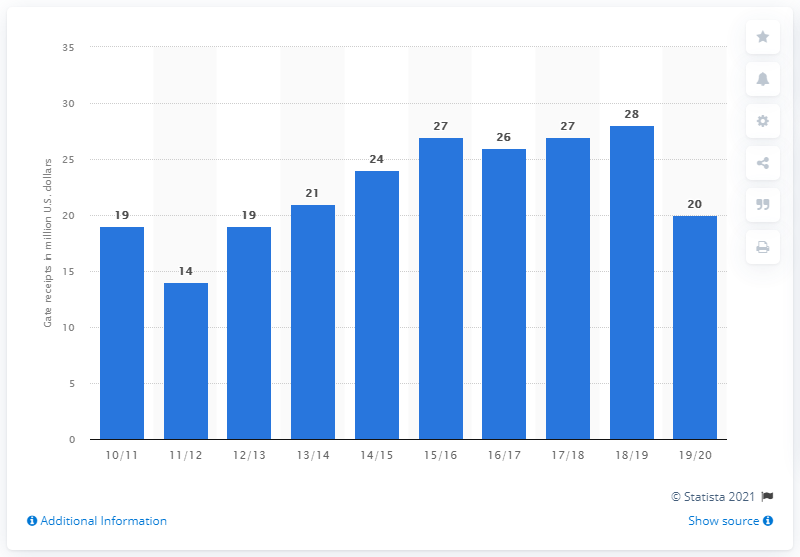Highlight a few significant elements in this photo. The total revenue generated from ticket sales for the Charlotte Hornets in the 2019/2020 season was approximately $20 million. 